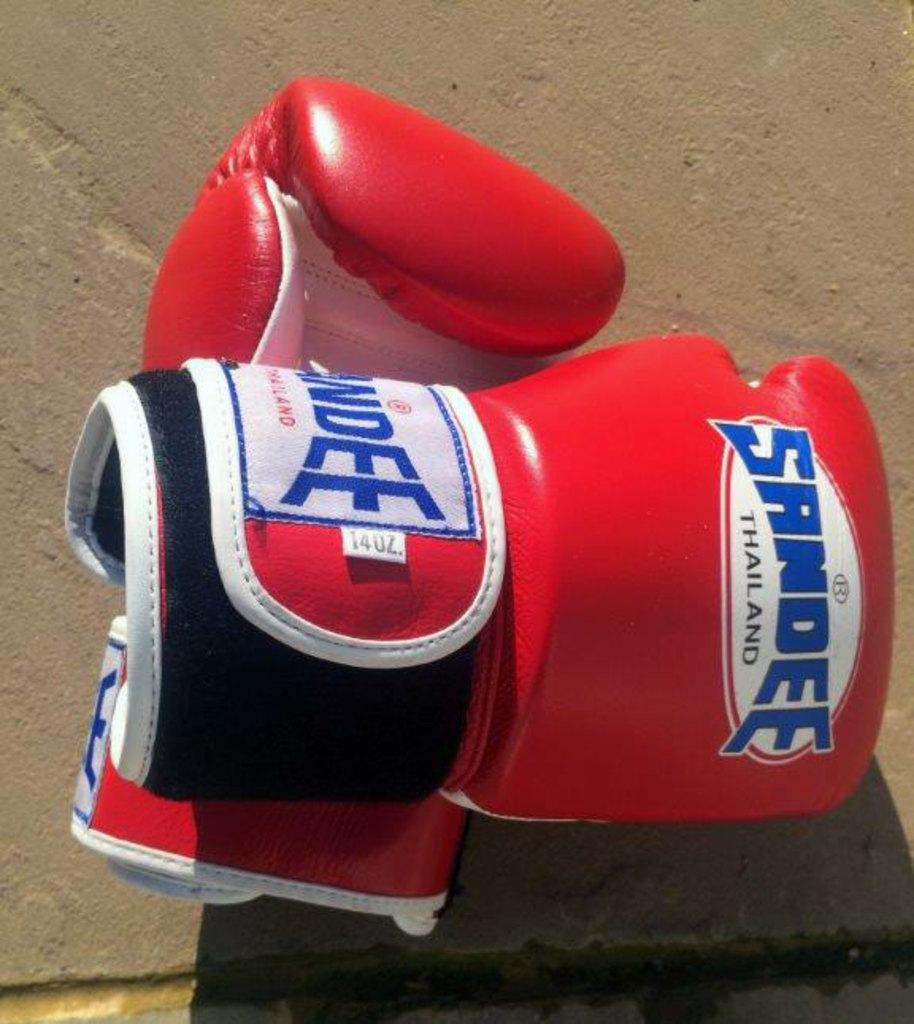<image>
Present a compact description of the photo's key features. sandee boxing gloves are resting on a concrete surface 